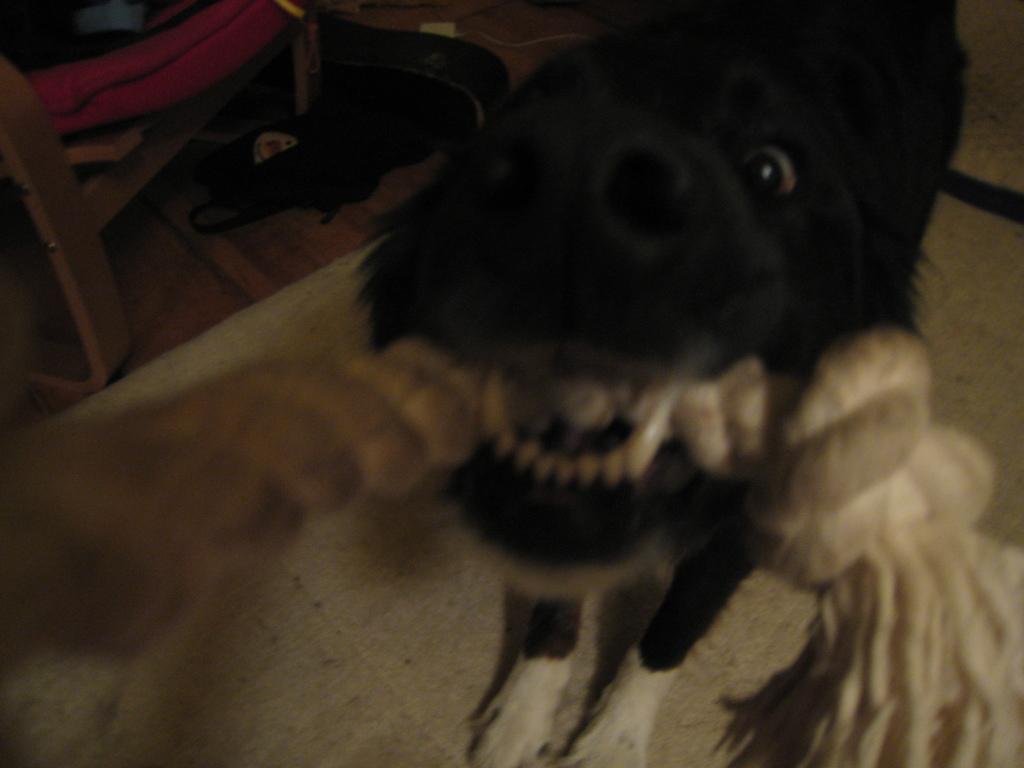How would you summarize this image in a sentence or two? In this image in front there is a dog holding some object in her mouth. Beside the dog there is another dog lying on the floor. There is a chair. 